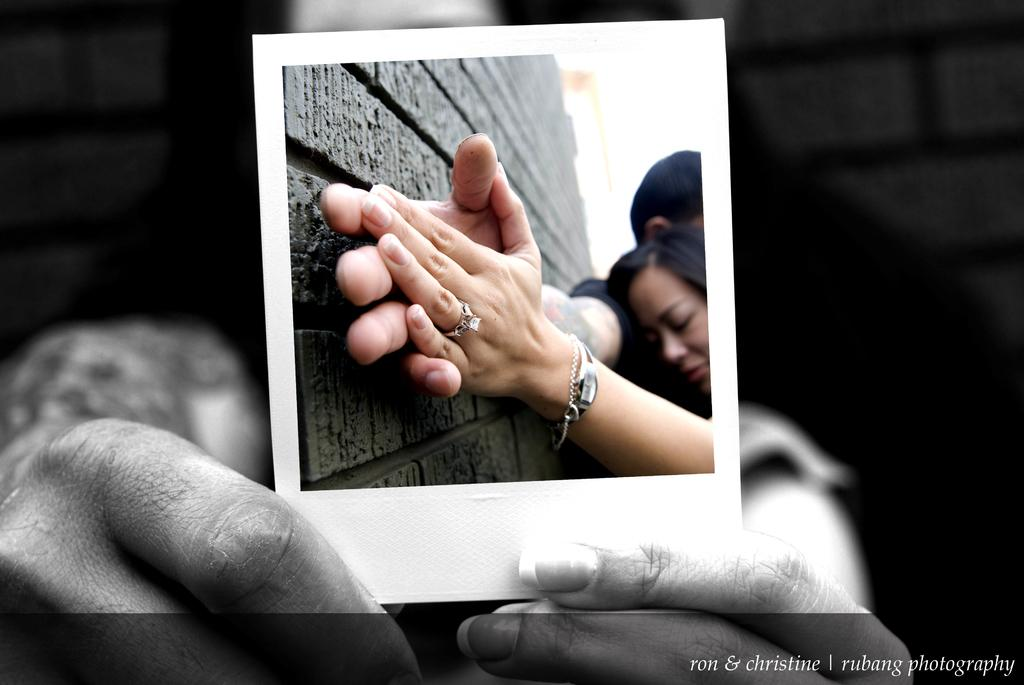What is the person in the image holding? The person in the image is holding a photograph. What can be seen in the photograph? The photograph contains a couple. How are the couple depicted in the photograph? The couple is holding hands together in the photograph. What type of dirt can be seen on the couple in the photograph? There is no dirt visible on the couple in the photograph; they appear clean and well-groomed. 